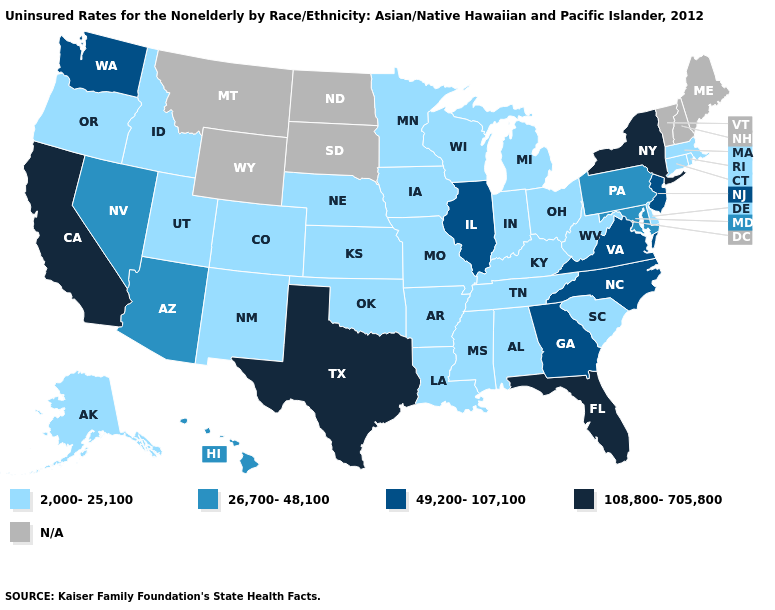What is the value of Iowa?
Give a very brief answer. 2,000-25,100. Does California have the highest value in the USA?
Concise answer only. Yes. What is the value of Arizona?
Answer briefly. 26,700-48,100. Among the states that border Nevada , which have the lowest value?
Short answer required. Idaho, Oregon, Utah. Does Arkansas have the highest value in the South?
Keep it brief. No. Is the legend a continuous bar?
Concise answer only. No. What is the lowest value in the USA?
Short answer required. 2,000-25,100. Name the states that have a value in the range 108,800-705,800?
Concise answer only. California, Florida, New York, Texas. Name the states that have a value in the range N/A?
Answer briefly. Maine, Montana, New Hampshire, North Dakota, South Dakota, Vermont, Wyoming. Name the states that have a value in the range 108,800-705,800?
Short answer required. California, Florida, New York, Texas. What is the highest value in the USA?
Concise answer only. 108,800-705,800. Which states have the lowest value in the USA?
Be succinct. Alabama, Alaska, Arkansas, Colorado, Connecticut, Delaware, Idaho, Indiana, Iowa, Kansas, Kentucky, Louisiana, Massachusetts, Michigan, Minnesota, Mississippi, Missouri, Nebraska, New Mexico, Ohio, Oklahoma, Oregon, Rhode Island, South Carolina, Tennessee, Utah, West Virginia, Wisconsin. 